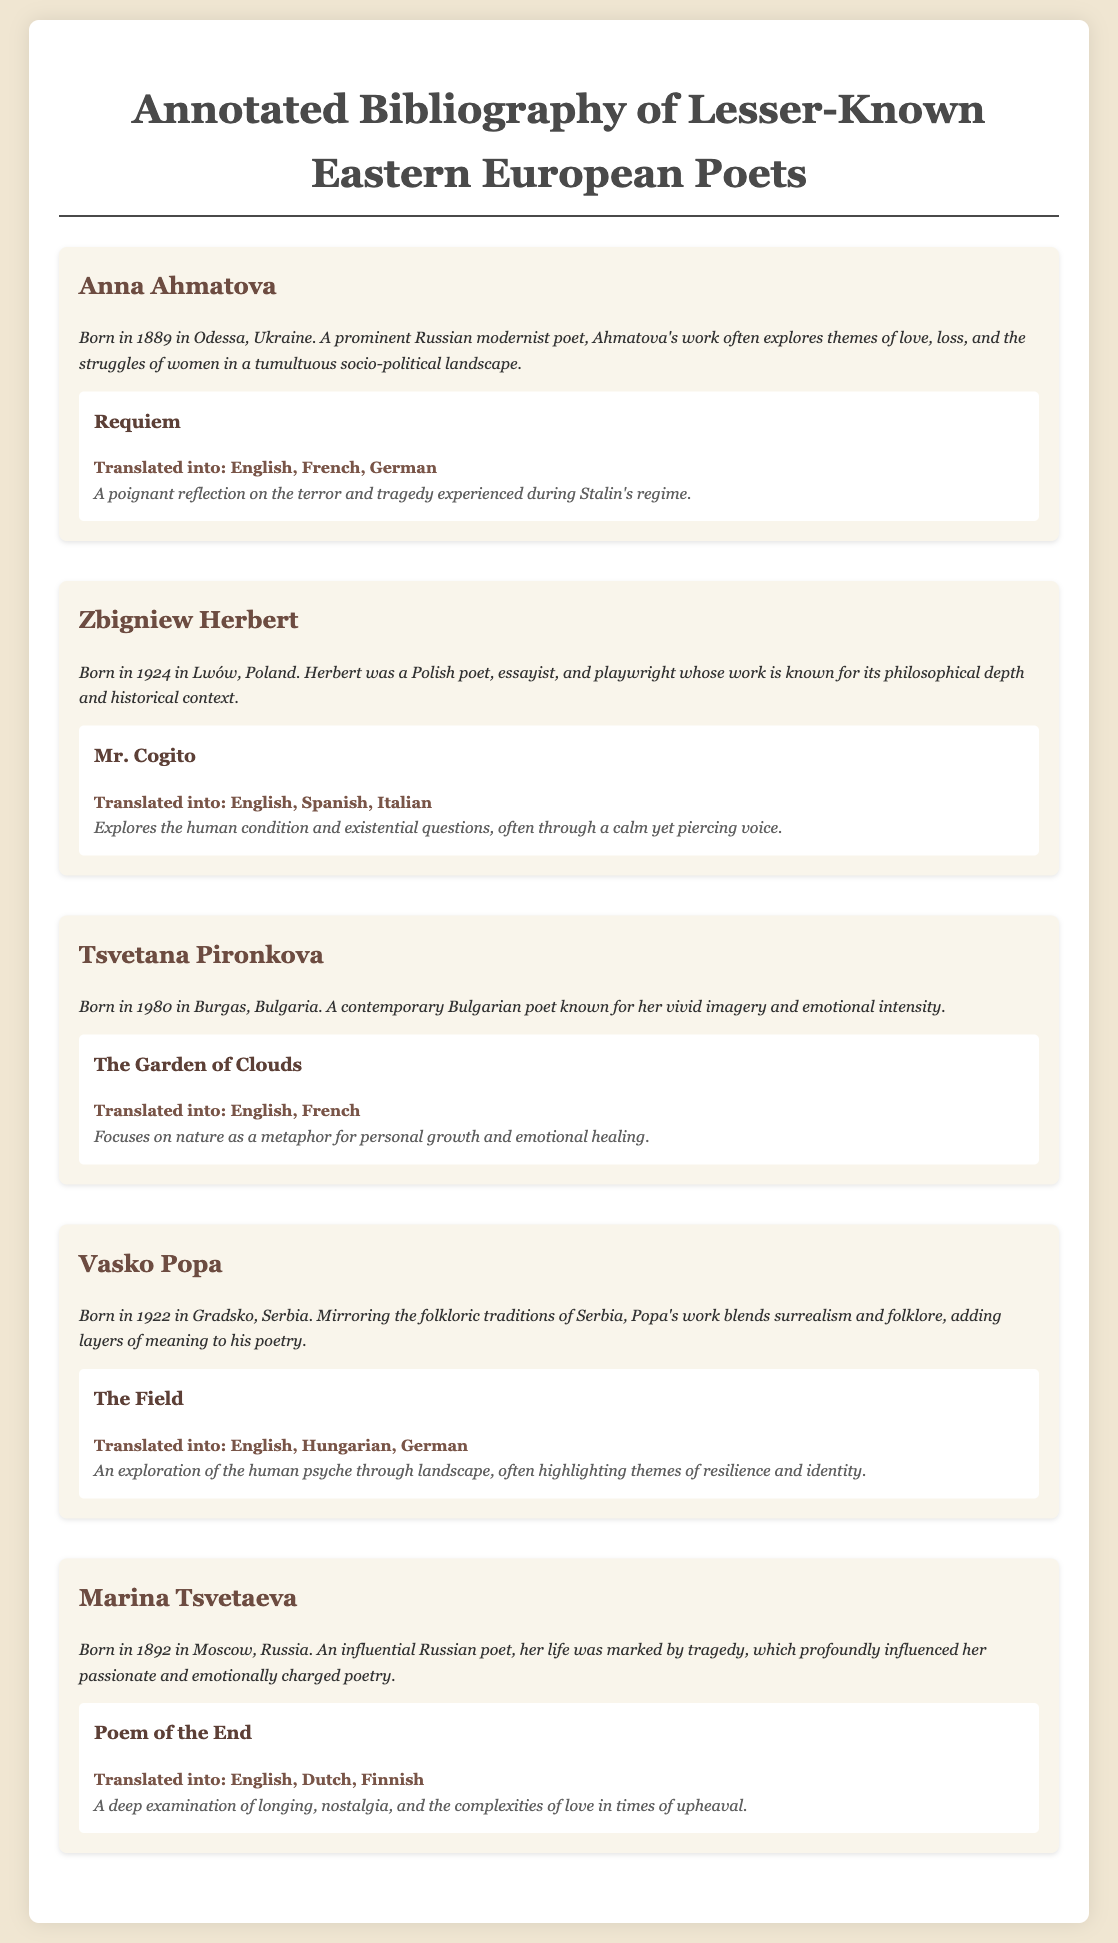What is the birth year of Anna Ahmatova? The document states that Anna Ahmatova was born in 1889.
Answer: 1889 Which poet's work is titled "Mr. Cogito"? The title "Mr. Cogito" belongs to the poet Zbigniew Herbert as mentioned in the document.
Answer: Zbigniew Herbert How many translations does "Requiem" have? The document lists three translations for "Requiem": English, French, and German.
Answer: 3 What theme is explored in Vasko Popa's "The Field"? According to the document, "The Field" explores themes of resilience and identity through landscape.
Answer: Resilience and identity Who is the contemporary Bulgarian poet mentioned in the document? The poet mentioned is Tsvetana Pironkova, noted for her vivid imagery.
Answer: Tsvetana Pironkova Which work by Marina Tsvetaeva is translated into Finnish? The document specifies that "Poem of the End" is translated into Finnish.
Answer: Poem of the End What year was Zbigniew Herbert born? The document indicates that Zbigniew Herbert was born in 1924.
Answer: 1924 What type of poetry is associated with Vasko Popa? Vasko Popa's poetry is described as blending surrealism and folklore.
Answer: Surrealism and folklore 